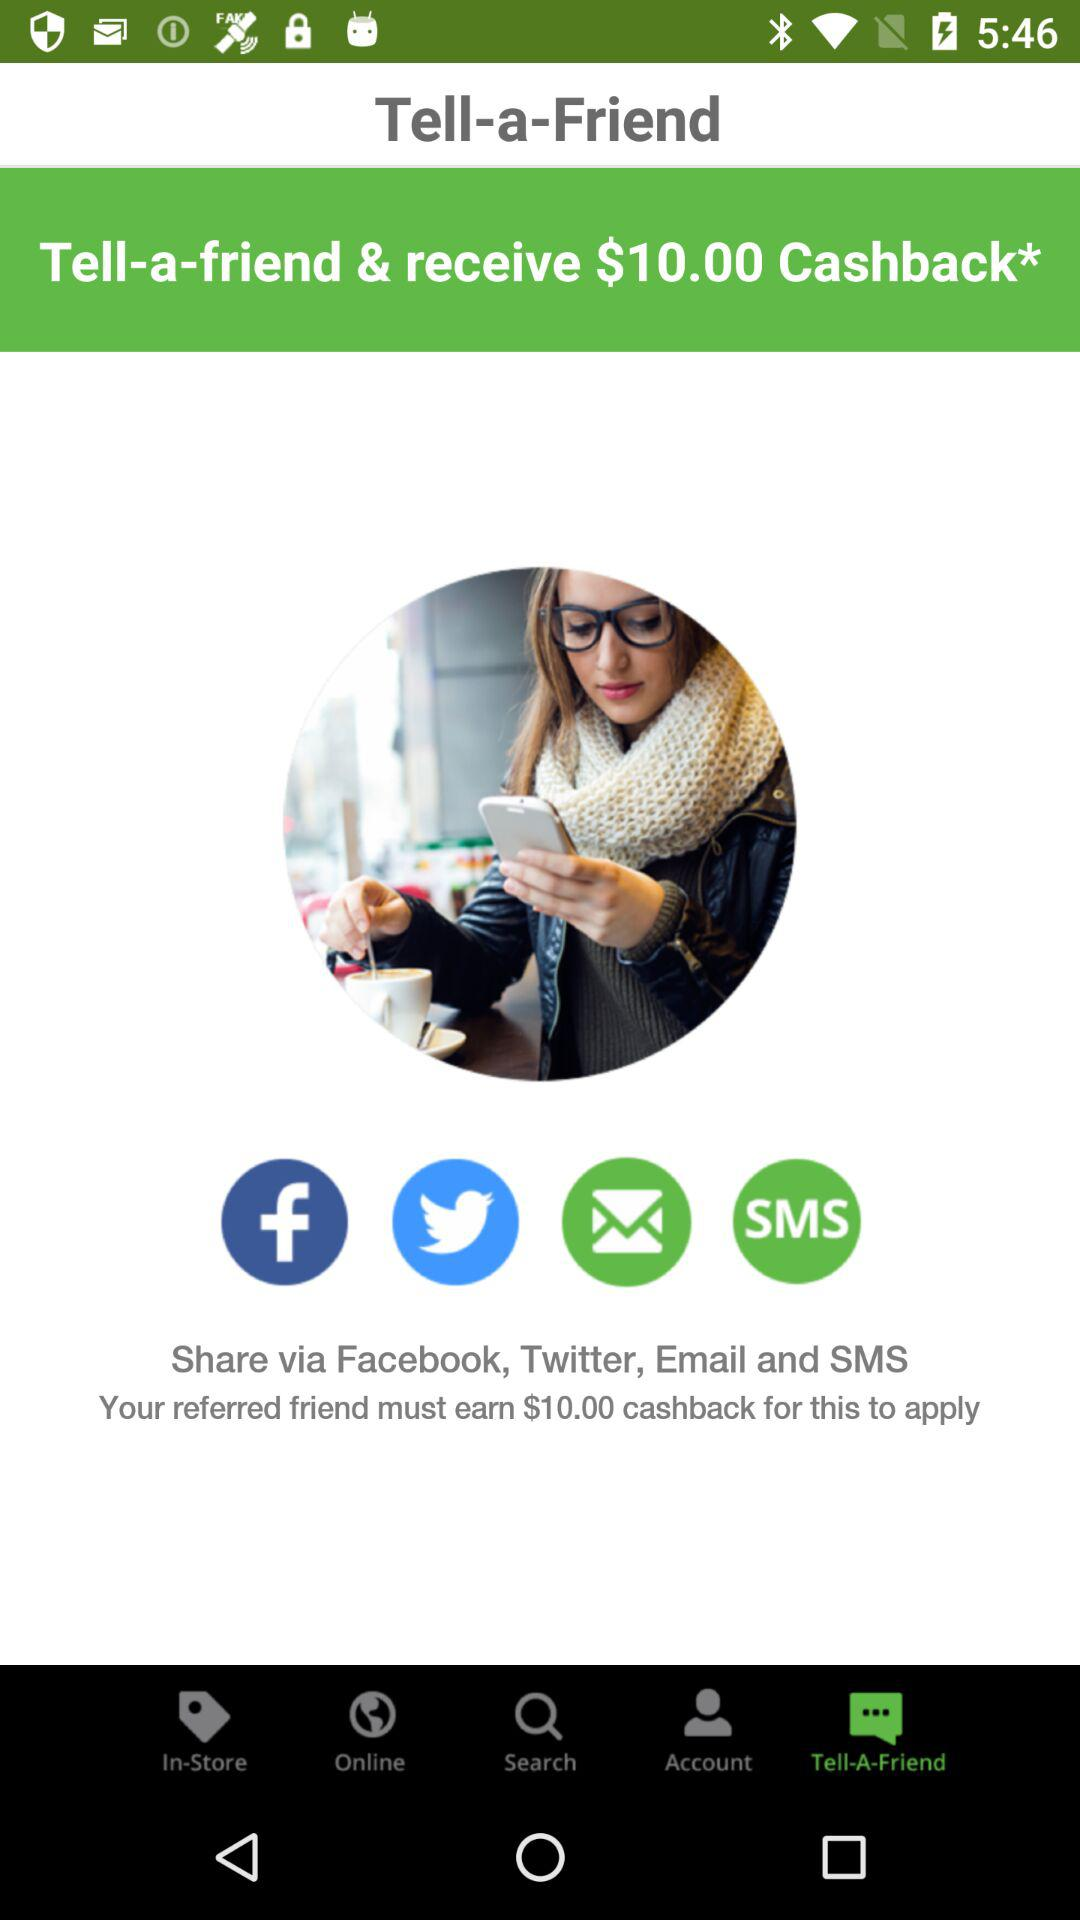How many social media platforms can you share the referral through?
Answer the question using a single word or phrase. 4 